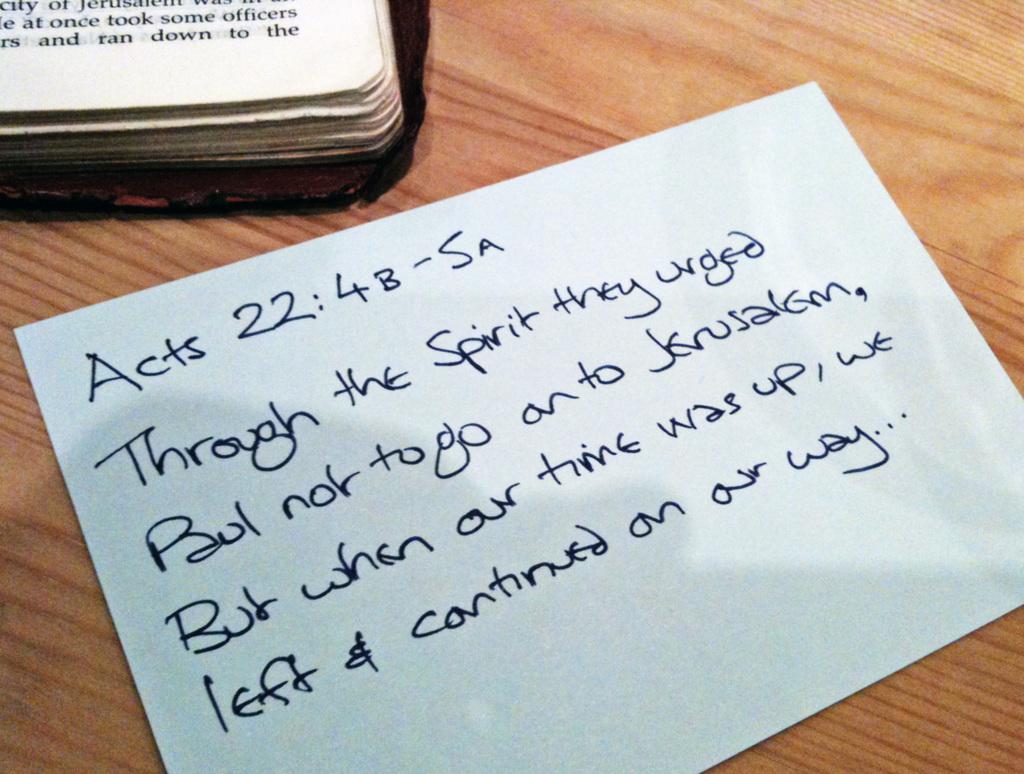What book is the quote from?
Your response must be concise. Acts. 